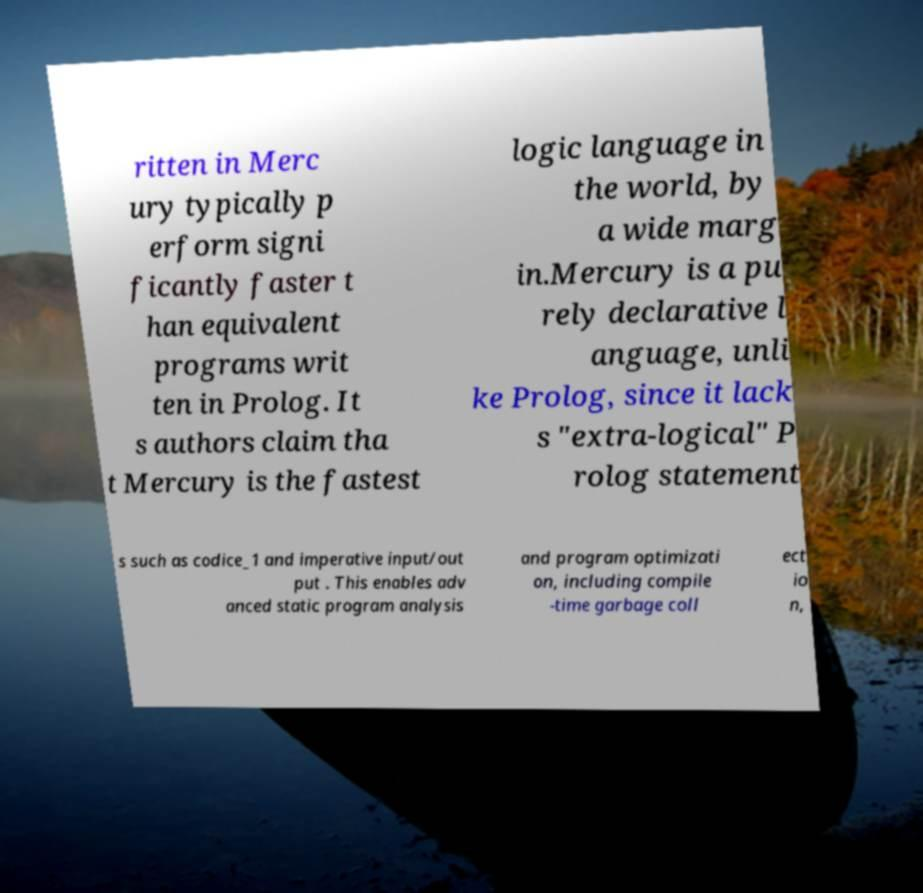Can you accurately transcribe the text from the provided image for me? ritten in Merc ury typically p erform signi ficantly faster t han equivalent programs writ ten in Prolog. It s authors claim tha t Mercury is the fastest logic language in the world, by a wide marg in.Mercury is a pu rely declarative l anguage, unli ke Prolog, since it lack s "extra-logical" P rolog statement s such as codice_1 and imperative input/out put . This enables adv anced static program analysis and program optimizati on, including compile -time garbage coll ect io n, 